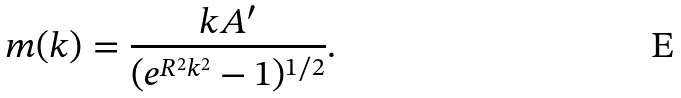<formula> <loc_0><loc_0><loc_500><loc_500>m ( k ) = \frac { k A ^ { \prime } } { ( e ^ { R ^ { 2 } k ^ { 2 } } - 1 ) ^ { 1 / 2 } } .</formula> 